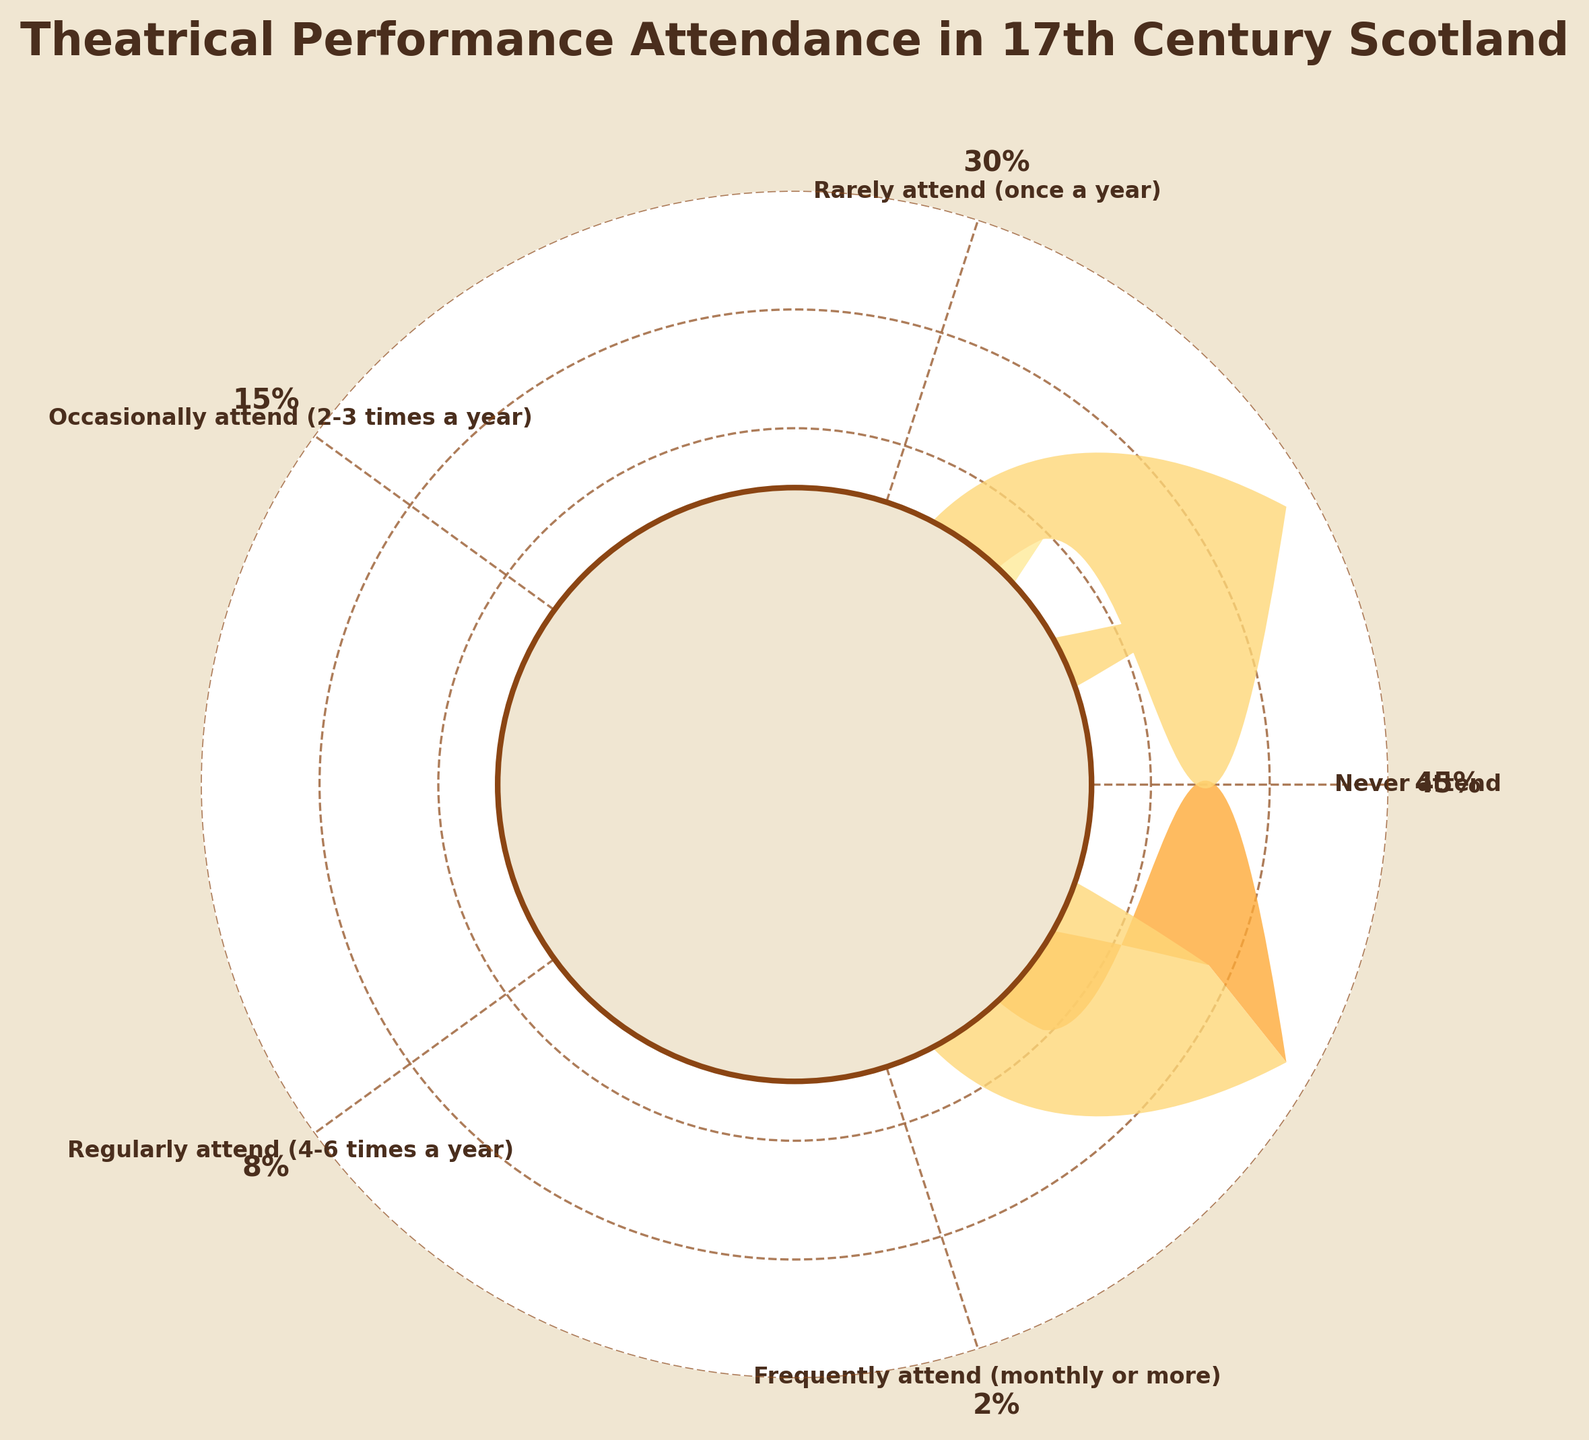What is the largest percentage category in the figure? The largest percentage category is represented by the widest wedge on the plot. The category labeled "Never attend" shows a percentage of 45%, which is the largest recorded percentage.
Answer: Never attend How many categories have a percentage higher than 10%? To determine this, identify and count all wedges displaying percentages above 10%. The categories "Never attend" (45%), "Rarely attend (once a year)" (30%), and "Occasionally attend (2-3 times a year)" (15%) all have percentages higher than 10%, totaling to three categories.
Answer: Three What is the combined percentage of people who attend theaters either rarely or occasionally? Combine the percentages of the categories "Rarely attend (once a year)" (30%) and "Occasionally attend (2-3 times a year)" (15%). Adding these together gives 30% + 15% = 45%.
Answer: 45% Which category has the smallest percentage and what is it? The smallest percentage can be found by locating the narrowest wedge on the plot. The category labeled "Frequently attend (monthly or more)" shows a percentage of 2%, which is the smallest recorded percentage.
Answer: Frequently attend (monthly or more), 2% Is there a greater percentage of people who rarely attend the theater compared to those who occasionally attend? To determine this, compare the percentages of the "Rarely attend (once a year)" and "Occasionally attend (2-3 times a year)" categories. "Rarely attend (once a year)" is at 30%, which is greater than "Occasionally attend (2-3 times a year)" at 15%.
Answer: Yes What percentage of the Scottish population attends theatrical performances regularly or frequently? Combine the percentages of the "Regularly attend (4-6 times a year)" (8%) and "Frequently attend (monthly or more)" (2%) categories. Adding these together gives 8% + 2% = 10%.
Answer: 10% How does the percentage of people who never attend compare to those who attend rarely? Compare the percentages for the categories "Never attend" (45%) and "Rarely attend (once a year)" (30%). The "Never attend" category is 15 percentage points larger than the "Rarely attend" category.
Answer: 45% vs. 30% What percentage of the population attends the theater at least occasionally? Combine the percentages for "Occasionally attend (2-3 times a year)", "Regularly attend (4-6 times a year)", and "Frequently attend (monthly or more)" categories. Adding these together gives 15% + 8% + 2% = 25%.
Answer: 25% Based on the chart, what can be inferred about the general frequency of theater attendance in 17th-century Scotland? The largest percentages appear in the "Never attend" and "Rarely attend" categories, showing that the majority rarely or never attend theatrical performances. The percentage gradually reduces as attendance frequency increases, inferring that frequent attendance is quite rare.
Answer: Majority rarely or never attend What is the median percentage value among all the attendance categories? To find the median, first list the percentages in numerical order: 2%, 8%, 15%, 30%, 45%. The median value is the middle one, which is 15%.
Answer: 15% 